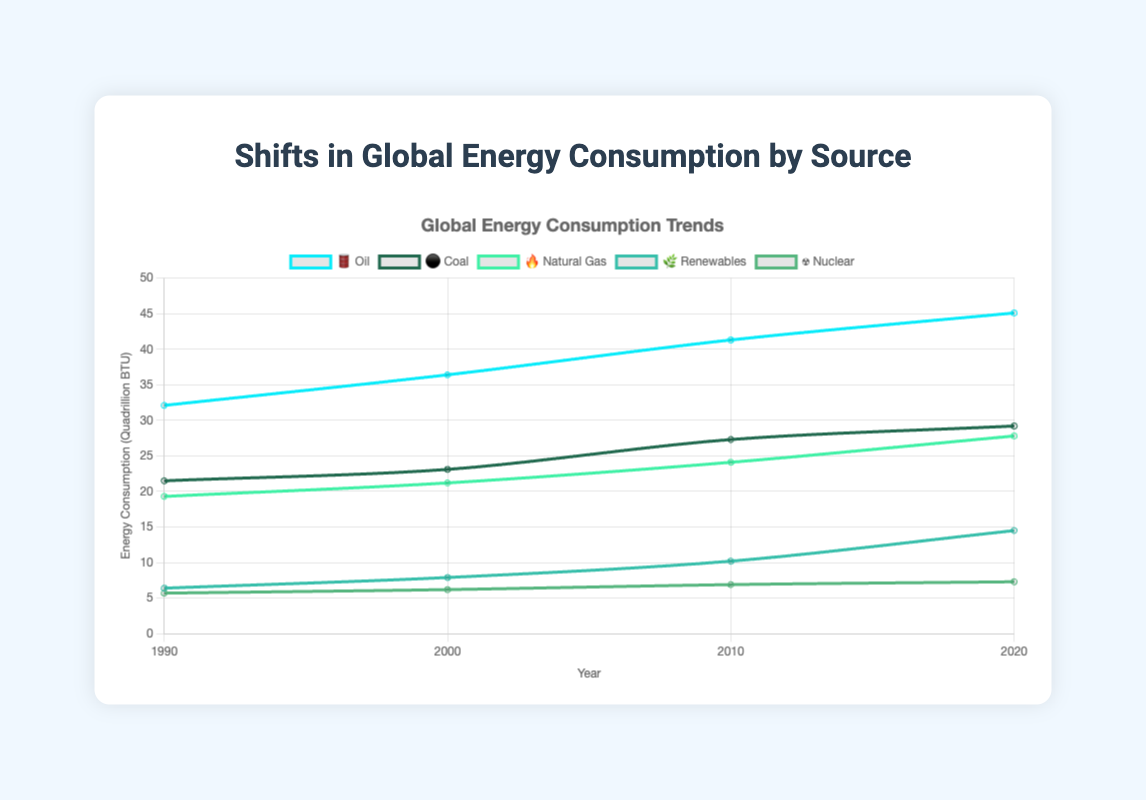What's the title of the figure? The title of the figure is typically found at the top. In this case, it says "Shifts in Global Energy Consumption by Source".
Answer: Shifts in Global Energy Consumption by Source Which energy source had the highest consumption in 2020? By looking at the 2020 data point, the highest value appears to belong to Oil 🛢️, which shows the highest endpoint at 45.1 Quadrillion BTU.
Answer: Oil 🛢️ What's the trend in consumption for renewables 🌿 from 1990 to 2020? The values of renewables increase from 6.4 in 1990 to 14.5 in 2020, indicating a continual rise in energy consumption.
Answer: Increasing How did coal ⚫ and natural gas 🔥 consumption compare in 2010? By examining the 2010 values, we see that coal has a value of 27.3 while natural gas is at 24.1. Thus, coal is consumed more than natural gas in 2010.
Answer: Coal ⚫ higher Which energy source showed the least growth over the 30-year period? Growth can be calculated by finding the difference between the 2020 and 1990 values for each source. Nuclear ☢️ shows the smallest increase (from 5.7 to 7.3).
Answer: Nuclear ☢️ Which two energy sources had the closest consumption values in 1990? By comparing the 1990 values, renewables (6.4) and nuclear (5.7) are closest to each other. The difference between them is 0.7.
Answer: Renewables 🌿 and Nuclear ☢️ Estimate the average consumption of oil 🛢️ over the years 1990, 2000, 2010, and 2020. The average can be found by summing the values and then dividing by the number of years: (32.1 + 36.4 + 41.3 + 45.1) / 4 = 38.725.
Answer: 38.725 Quadrillion BTU Did any energy source's consumption decline between 1990 and 2020? By checking the values across the years, no energy source shows a decline; all have increased over time.
Answer: No In which year did oil 🛢️ consume more than 40 Quadrillion BTU? Referring to the figure, oil consumption exceeds 40 Quadrillion BTU starting in 2010.
Answer: 2010 Order the energy sources by their consumption values in 2000, from highest to lowest. In 2000, the consumption values are: Oil 🛢️ (36.4), Coal ⚫ (23.1), Natural Gas 🔥 (21.2), Renewables 🌿 (7.9), Nuclear ☢️ (6.2).
Answer: Oil 🛢️, Coal ⚫, Natural Gas 🔥, Renewables 🌿, Nuclear ☢️ 